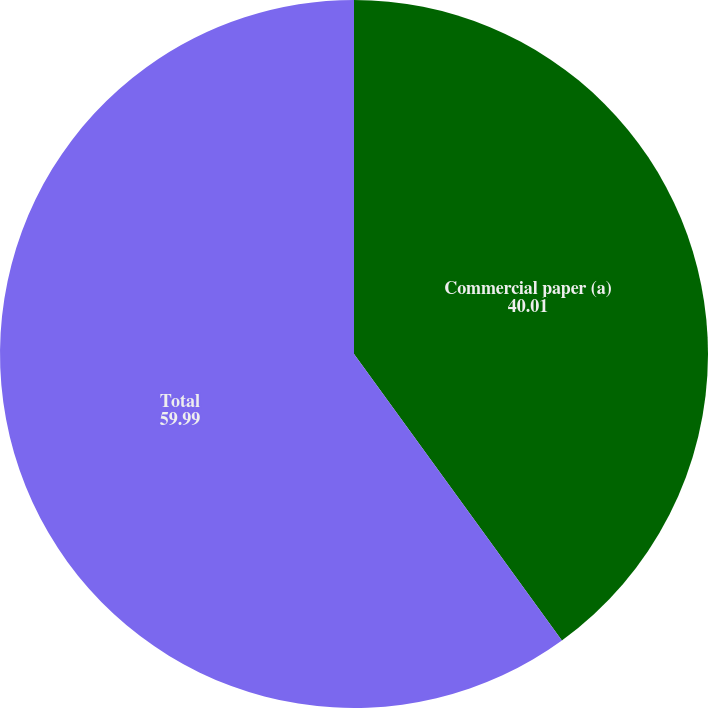Convert chart to OTSL. <chart><loc_0><loc_0><loc_500><loc_500><pie_chart><fcel>Commercial paper (a)<fcel>Total<nl><fcel>40.01%<fcel>59.99%<nl></chart> 